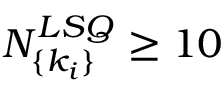Convert formula to latex. <formula><loc_0><loc_0><loc_500><loc_500>N _ { \{ k _ { i } \} } ^ { L S Q } \geq 1 0</formula> 